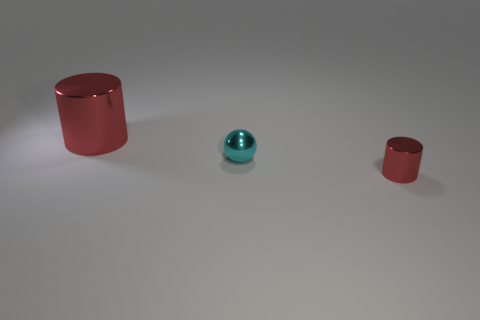Add 3 small yellow matte things. How many objects exist? 6 Subtract all balls. How many objects are left? 2 Add 2 tiny shiny cylinders. How many tiny shiny cylinders exist? 3 Subtract 0 gray cubes. How many objects are left? 3 Subtract all red blocks. Subtract all shiny spheres. How many objects are left? 2 Add 2 small red objects. How many small red objects are left? 3 